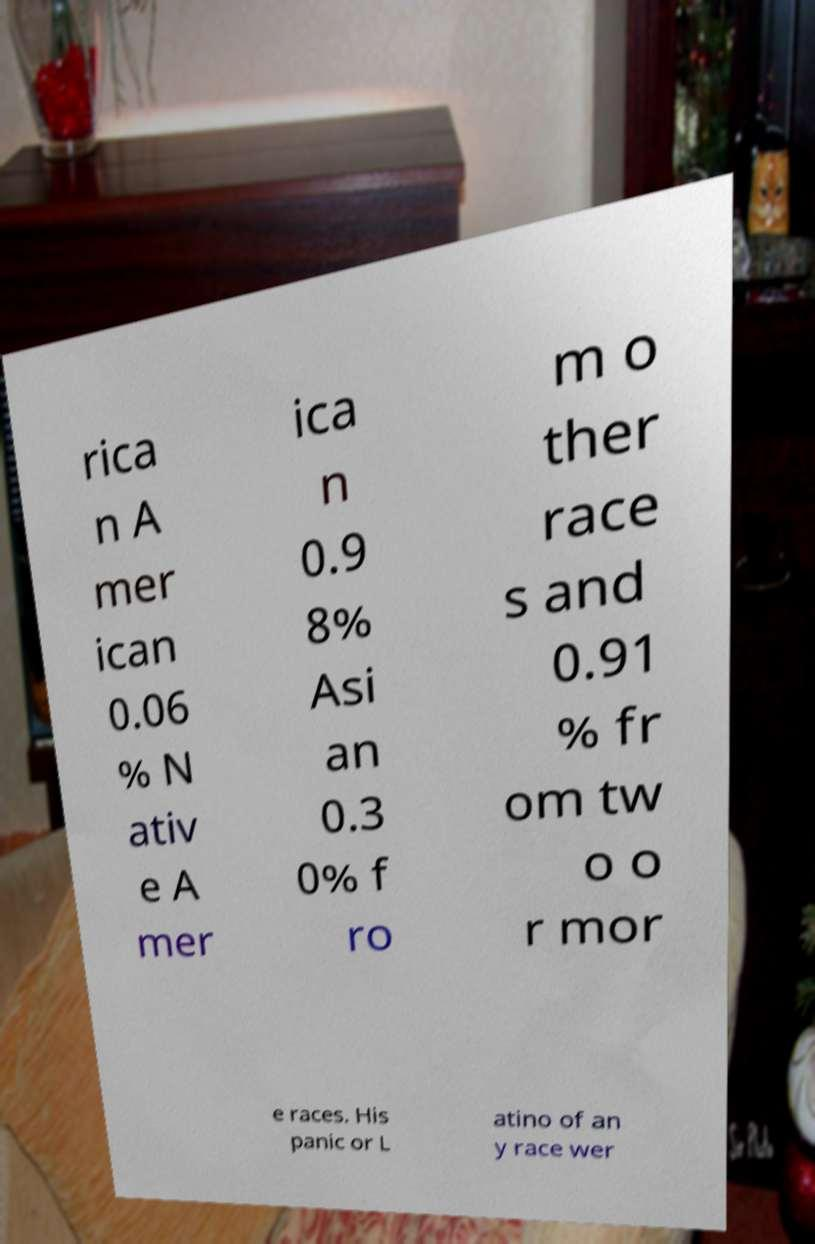For documentation purposes, I need the text within this image transcribed. Could you provide that? rica n A mer ican 0.06 % N ativ e A mer ica n 0.9 8% Asi an 0.3 0% f ro m o ther race s and 0.91 % fr om tw o o r mor e races. His panic or L atino of an y race wer 